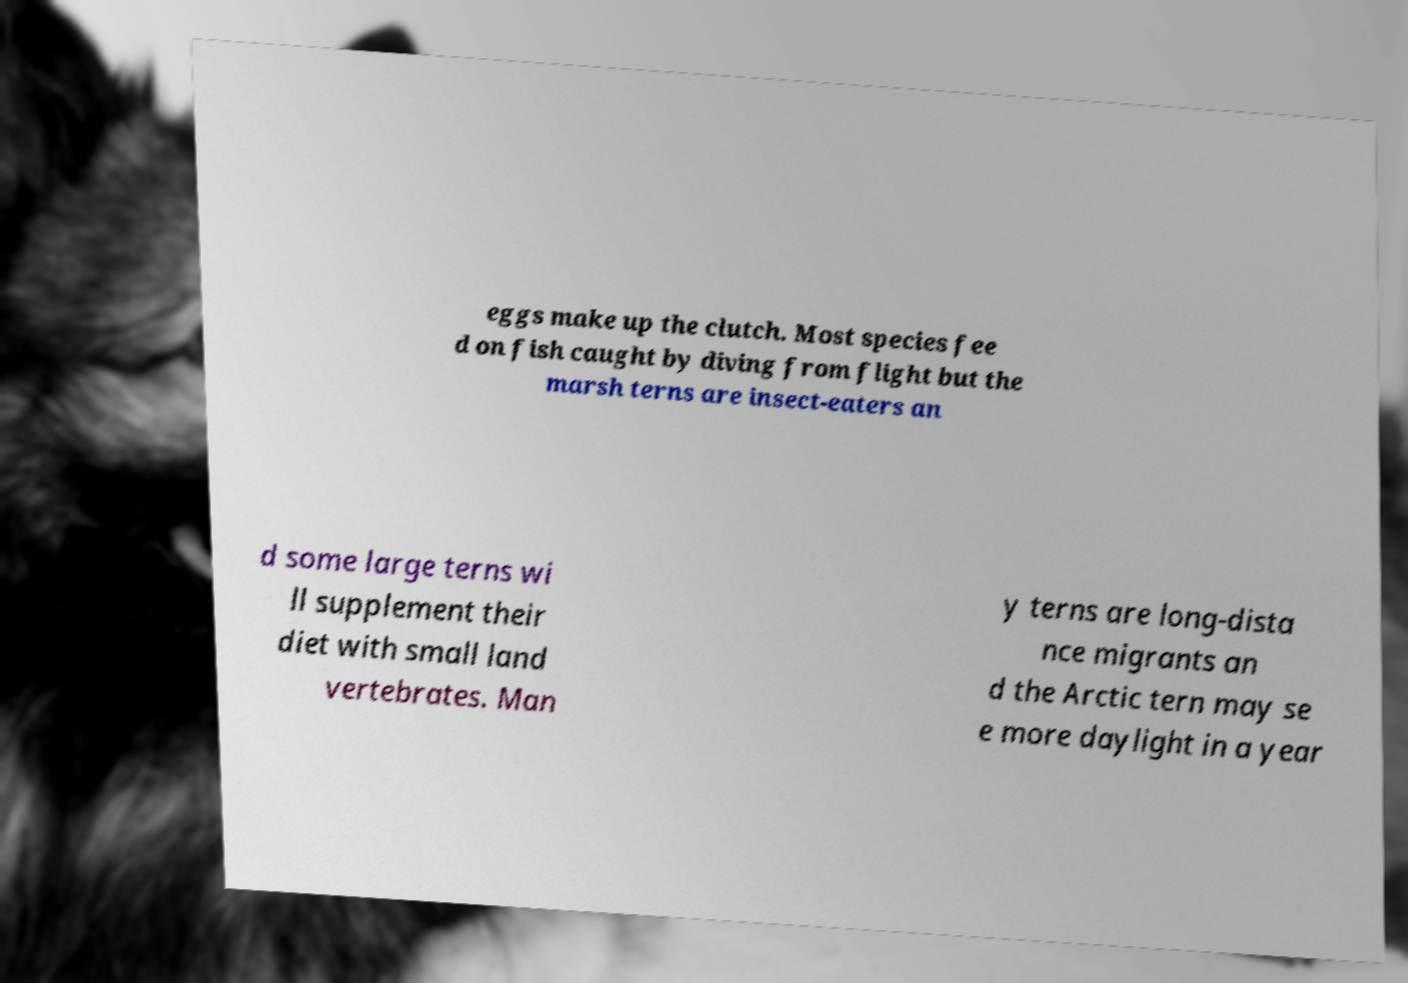Can you read and provide the text displayed in the image?This photo seems to have some interesting text. Can you extract and type it out for me? eggs make up the clutch. Most species fee d on fish caught by diving from flight but the marsh terns are insect-eaters an d some large terns wi ll supplement their diet with small land vertebrates. Man y terns are long-dista nce migrants an d the Arctic tern may se e more daylight in a year 